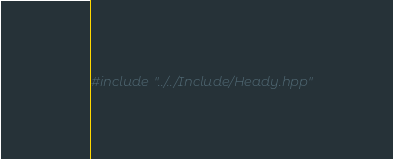Convert code to text. <code><loc_0><loc_0><loc_500><loc_500><_C_>
#include "../../Include/Heady.hpp"
</code> 